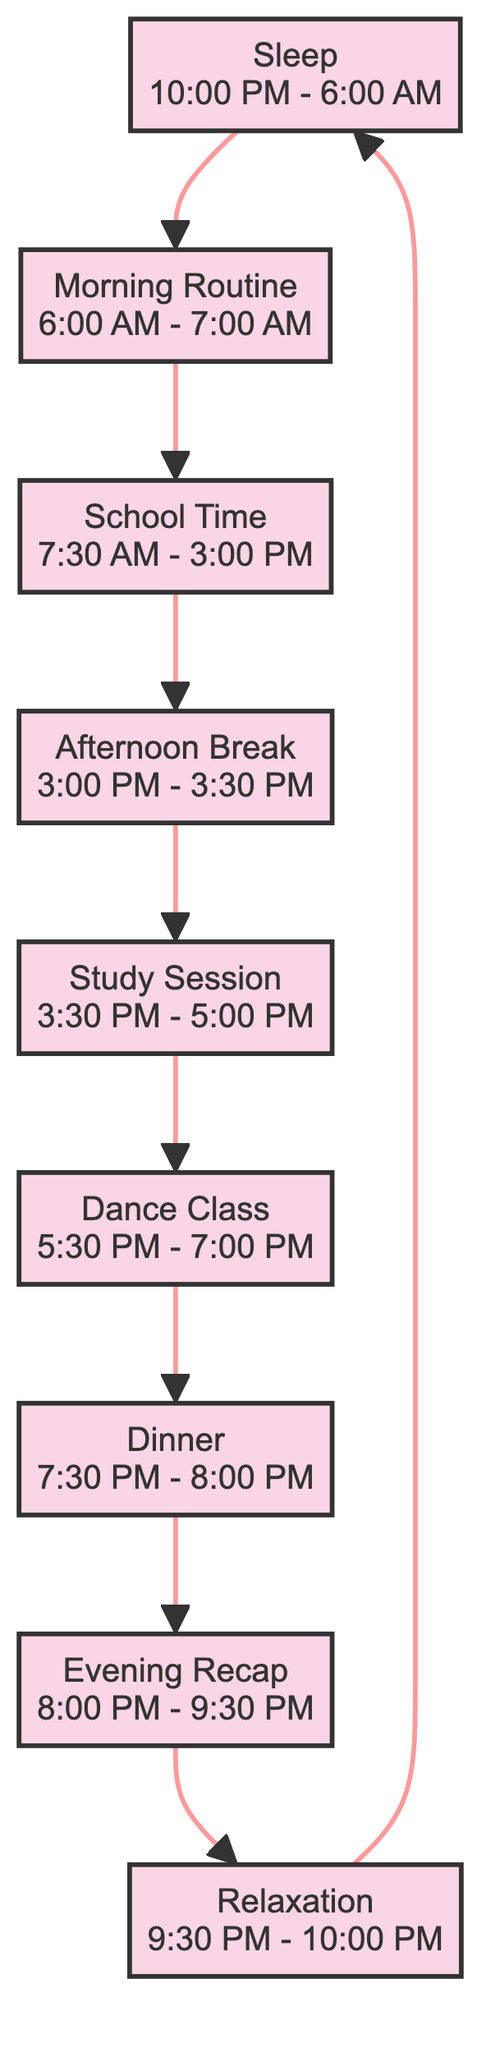What is the first activity in the routine? The diagram starts with the "Sleep" node, which is the first activity listed in the flow from bottom to up.
Answer: Sleep How long is the School Time? The "School Time" node indicates that it lasts from 7:30 AM to 3:00 PM, equating to a duration of 7 hours and 30 minutes.
Answer: 7 hours 30 minutes What comes directly after the Afternoon Break? According to the flowchart, the direct successor to the "Afternoon Break" node is the "Study Session" node.
Answer: Study Session How many total activities are there in the routine? Counting each node in the flowchart, there are a total of 9 activities listed in the daily routine.
Answer: 9 Which activity follows the Evening Recap? The flowchart indicates that "Relaxation" follows "Evening Recap," as it is the next node in the upward flow.
Answer: Relaxation Which two activities are connected by a direct flow? The "Study Session" and "Dance Class" nodes are directly connected; the flow moves from "Study Session" to "Dance Class."
Answer: Study Session and Dance Class What is the duration of the Dance Class? The "Dance Class" node specifies it lasts from 5:30 PM to 7:00 PM, which totals 1 hour and 30 minutes.
Answer: 1 hour 30 minutes What is the main focus of the Evening Recap? The "Evening Recap" node summarizes the activities of reviewing daily study notes and practicing dance routines, indicating its dual focus.
Answer: Review study notes and practice dance routines At what time does the Relaxation period start? The diagram states that "Relaxation" begins at 9:30 PM, as labeled in the flowchart.
Answer: 9:30 PM 